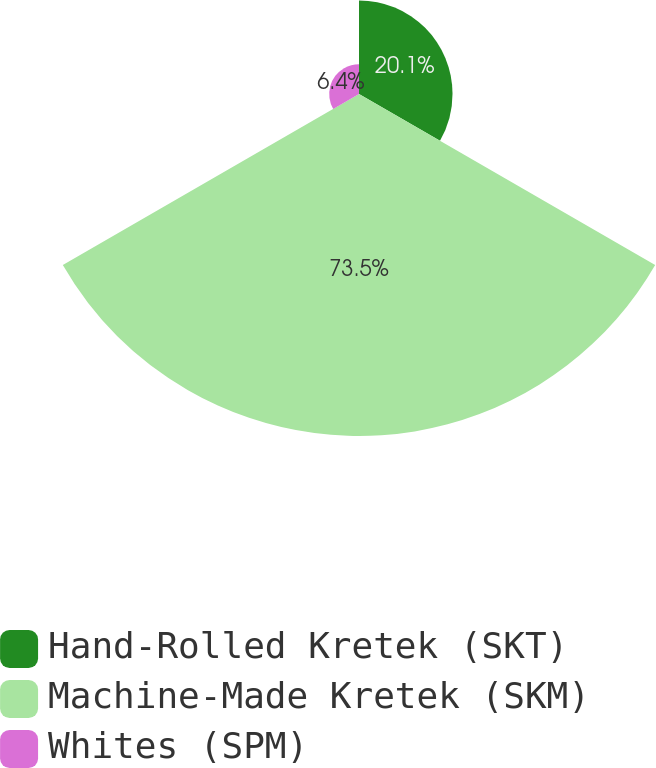<chart> <loc_0><loc_0><loc_500><loc_500><pie_chart><fcel>Hand-Rolled Kretek (SKT)<fcel>Machine-Made Kretek (SKM)<fcel>Whites (SPM)<nl><fcel>20.1%<fcel>73.5%<fcel>6.4%<nl></chart> 